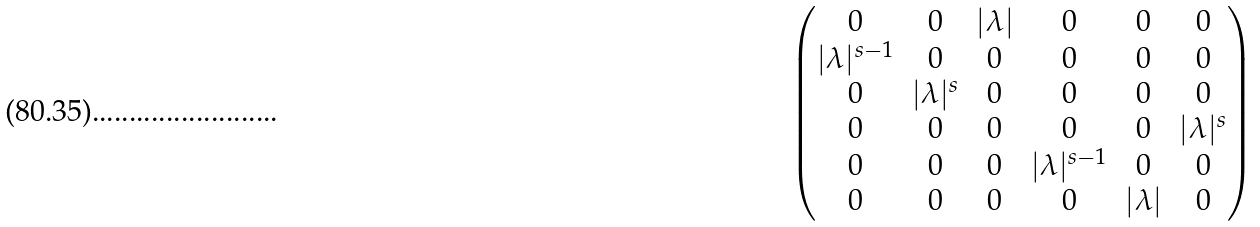Convert formula to latex. <formula><loc_0><loc_0><loc_500><loc_500>\begin{pmatrix} 0 & 0 & | \lambda | & 0 & 0 & 0 \\ | \lambda | ^ { s - 1 } & 0 & 0 & 0 & 0 & 0 \\ 0 & | \lambda | ^ { s } & 0 & 0 & 0 & 0 \\ 0 & 0 & 0 & 0 & 0 & | \lambda | ^ { s } \\ 0 & 0 & 0 & | \lambda | ^ { s - 1 } & 0 & 0 \\ 0 & 0 & 0 & 0 & | \lambda | & 0 \end{pmatrix}</formula> 